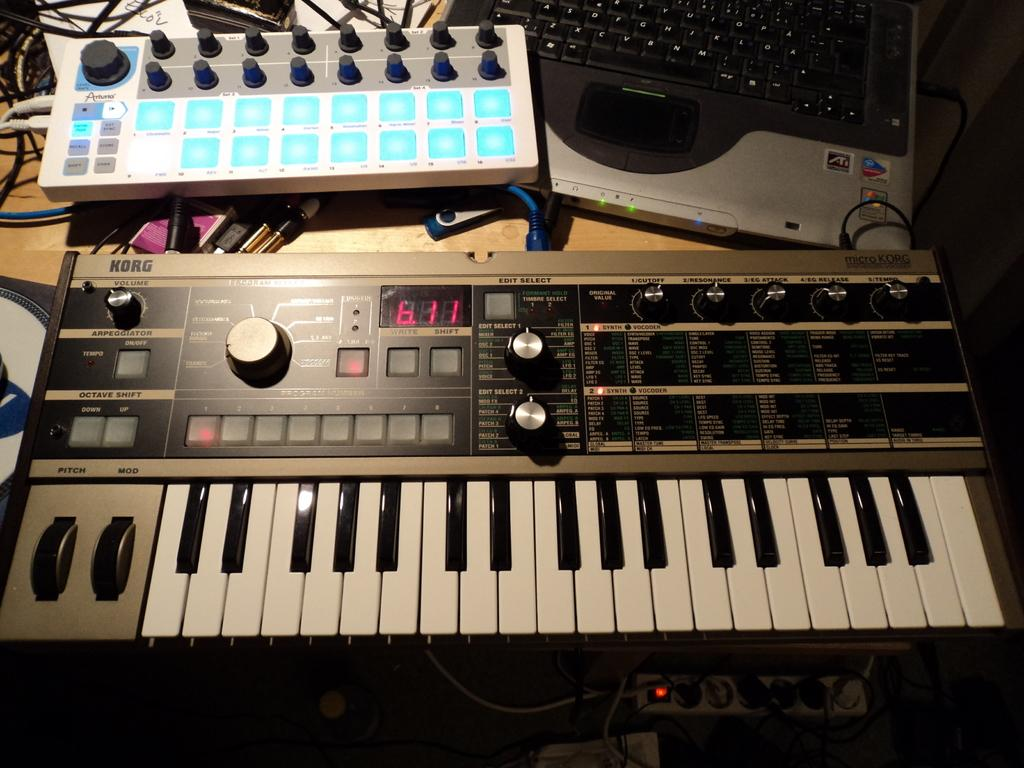What type of electronic device is present in the image? There is a laptop in the image. What other electronic device can be seen in the image? There is a keyboard and a musical pad in the image. Are there any visible connections between the devices? Yes, there are wires visible in the image. What type of frame is holding the lizards in the image? There are no lizards present in the image, so there is no frame holding them. Can you recite the verse that is written on the musical pad in the image? There is no verse written on the musical pad in the image; it is an electronic device for making music. 